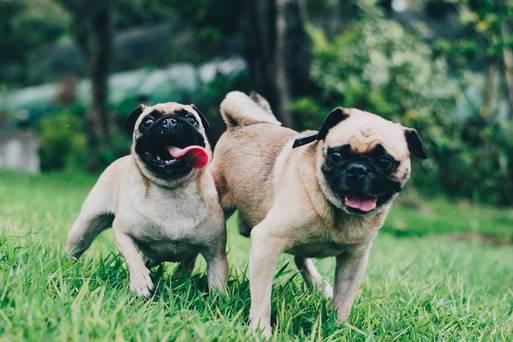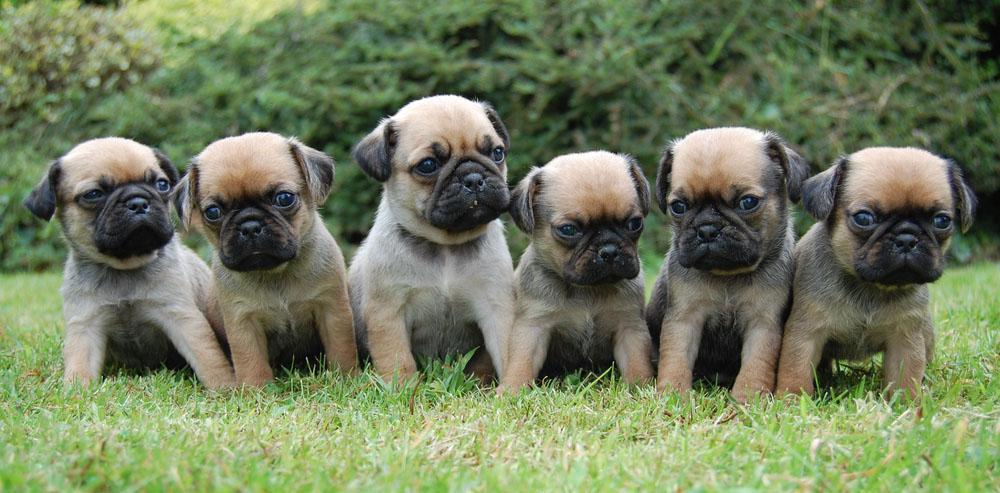The first image is the image on the left, the second image is the image on the right. Assess this claim about the two images: "there is at least one dog in the image pair running and none of it's feet are touching the ground". Correct or not? Answer yes or no. No. The first image is the image on the left, the second image is the image on the right. Examine the images to the left and right. Is the description "There are at least four pugs in total." accurate? Answer yes or no. Yes. 